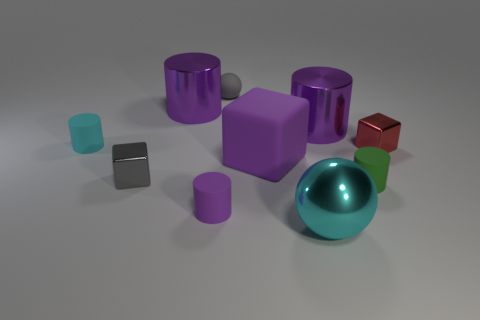Subtract all purple cylinders. How many were subtracted if there are2purple cylinders left? 1 Subtract all spheres. How many objects are left? 8 Subtract 2 blocks. How many blocks are left? 1 Subtract all cyan cubes. Subtract all cyan cylinders. How many cubes are left? 3 Subtract all green cylinders. How many gray cubes are left? 1 Subtract all big cyan metallic objects. Subtract all small green cylinders. How many objects are left? 8 Add 3 cyan cylinders. How many cyan cylinders are left? 4 Add 5 red metallic cubes. How many red metallic cubes exist? 6 Subtract all gray spheres. How many spheres are left? 1 Subtract all purple metal cylinders. How many cylinders are left? 3 